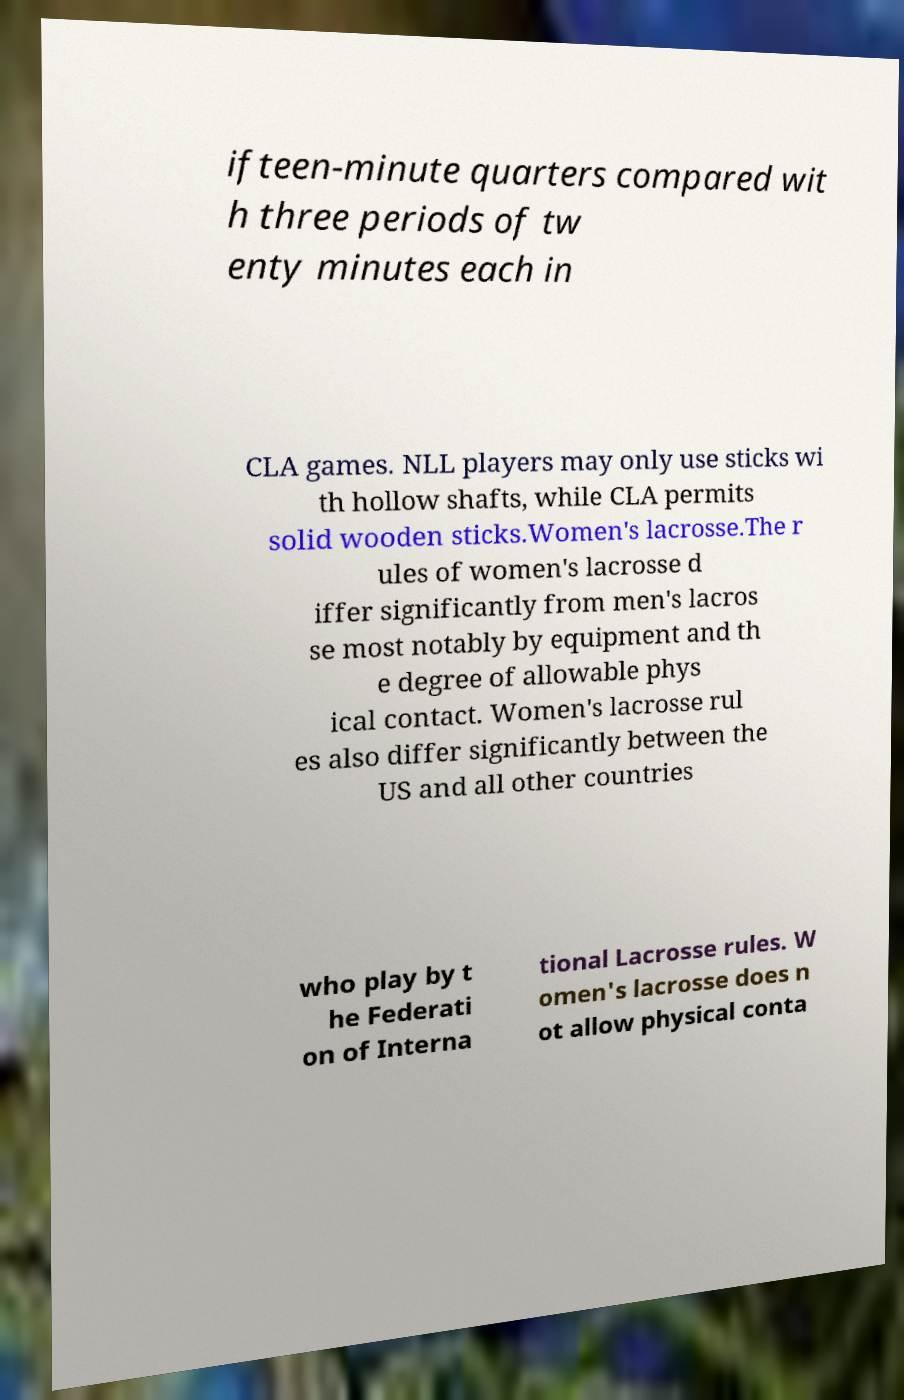Could you assist in decoding the text presented in this image and type it out clearly? ifteen-minute quarters compared wit h three periods of tw enty minutes each in CLA games. NLL players may only use sticks wi th hollow shafts, while CLA permits solid wooden sticks.Women's lacrosse.The r ules of women's lacrosse d iffer significantly from men's lacros se most notably by equipment and th e degree of allowable phys ical contact. Women's lacrosse rul es also differ significantly between the US and all other countries who play by t he Federati on of Interna tional Lacrosse rules. W omen's lacrosse does n ot allow physical conta 